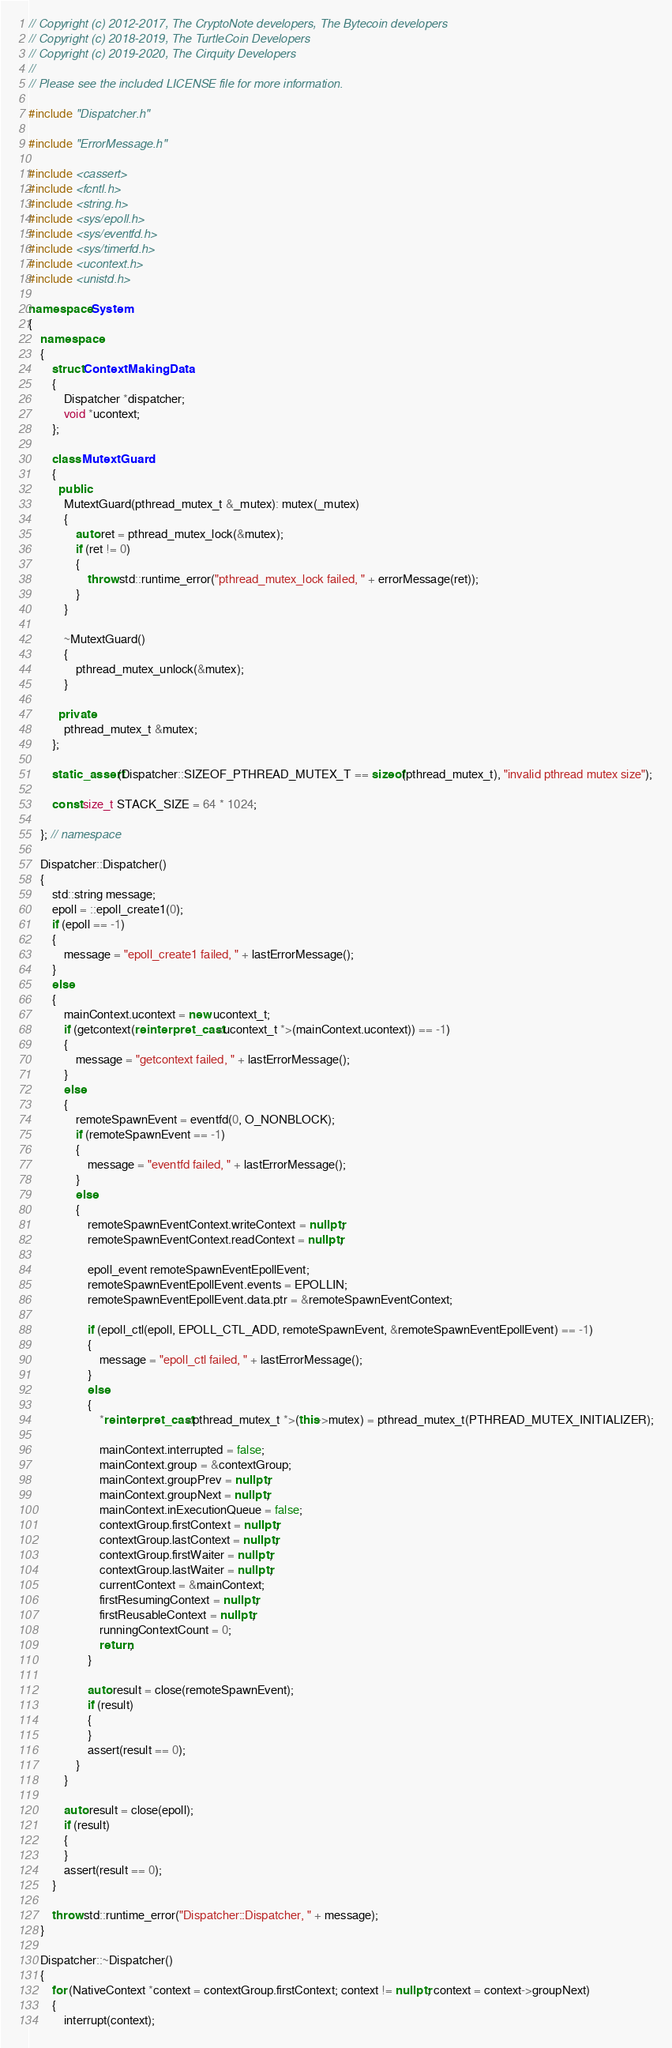Convert code to text. <code><loc_0><loc_0><loc_500><loc_500><_C++_>// Copyright (c) 2012-2017, The CryptoNote developers, The Bytecoin developers
// Copyright (c) 2018-2019, The TurtleCoin Developers
// Copyright (c) 2019-2020, The Cirquity Developers
//
// Please see the included LICENSE file for more information.

#include "Dispatcher.h"

#include "ErrorMessage.h"

#include <cassert>
#include <fcntl.h>
#include <string.h>
#include <sys/epoll.h>
#include <sys/eventfd.h>
#include <sys/timerfd.h>
#include <ucontext.h>
#include <unistd.h>

namespace System
{
    namespace
    {
        struct ContextMakingData
        {
            Dispatcher *dispatcher;
            void *ucontext;
        };

        class MutextGuard
        {
          public:
            MutextGuard(pthread_mutex_t &_mutex): mutex(_mutex)
            {
                auto ret = pthread_mutex_lock(&mutex);
                if (ret != 0)
                {
                    throw std::runtime_error("pthread_mutex_lock failed, " + errorMessage(ret));
                }
            }

            ~MutextGuard()
            {
                pthread_mutex_unlock(&mutex);
            }

          private:
            pthread_mutex_t &mutex;
        };

        static_assert(Dispatcher::SIZEOF_PTHREAD_MUTEX_T == sizeof(pthread_mutex_t), "invalid pthread mutex size");

        const size_t STACK_SIZE = 64 * 1024;

    }; // namespace

    Dispatcher::Dispatcher()
    {
        std::string message;
        epoll = ::epoll_create1(0);
        if (epoll == -1)
        {
            message = "epoll_create1 failed, " + lastErrorMessage();
        }
        else
        {
            mainContext.ucontext = new ucontext_t;
            if (getcontext(reinterpret_cast<ucontext_t *>(mainContext.ucontext)) == -1)
            {
                message = "getcontext failed, " + lastErrorMessage();
            }
            else
            {
                remoteSpawnEvent = eventfd(0, O_NONBLOCK);
                if (remoteSpawnEvent == -1)
                {
                    message = "eventfd failed, " + lastErrorMessage();
                }
                else
                {
                    remoteSpawnEventContext.writeContext = nullptr;
                    remoteSpawnEventContext.readContext = nullptr;

                    epoll_event remoteSpawnEventEpollEvent;
                    remoteSpawnEventEpollEvent.events = EPOLLIN;
                    remoteSpawnEventEpollEvent.data.ptr = &remoteSpawnEventContext;

                    if (epoll_ctl(epoll, EPOLL_CTL_ADD, remoteSpawnEvent, &remoteSpawnEventEpollEvent) == -1)
                    {
                        message = "epoll_ctl failed, " + lastErrorMessage();
                    }
                    else
                    {
                        *reinterpret_cast<pthread_mutex_t *>(this->mutex) = pthread_mutex_t(PTHREAD_MUTEX_INITIALIZER);

                        mainContext.interrupted = false;
                        mainContext.group = &contextGroup;
                        mainContext.groupPrev = nullptr;
                        mainContext.groupNext = nullptr;
                        mainContext.inExecutionQueue = false;
                        contextGroup.firstContext = nullptr;
                        contextGroup.lastContext = nullptr;
                        contextGroup.firstWaiter = nullptr;
                        contextGroup.lastWaiter = nullptr;
                        currentContext = &mainContext;
                        firstResumingContext = nullptr;
                        firstReusableContext = nullptr;
                        runningContextCount = 0;
                        return;
                    }

                    auto result = close(remoteSpawnEvent);
                    if (result)
                    {
                    }
                    assert(result == 0);
                }
            }

            auto result = close(epoll);
            if (result)
            {
            }
            assert(result == 0);
        }

        throw std::runtime_error("Dispatcher::Dispatcher, " + message);
    }

    Dispatcher::~Dispatcher()
    {
        for (NativeContext *context = contextGroup.firstContext; context != nullptr; context = context->groupNext)
        {
            interrupt(context);</code> 